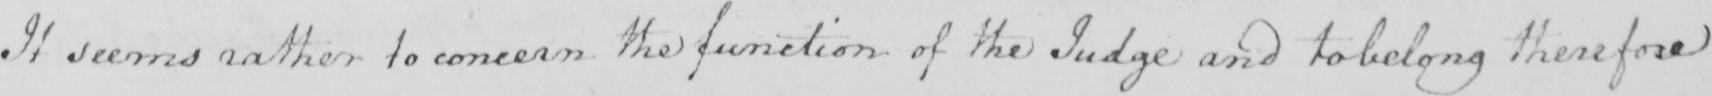What does this handwritten line say? It seems rather to concern the function of the Judge and to belong therefore 